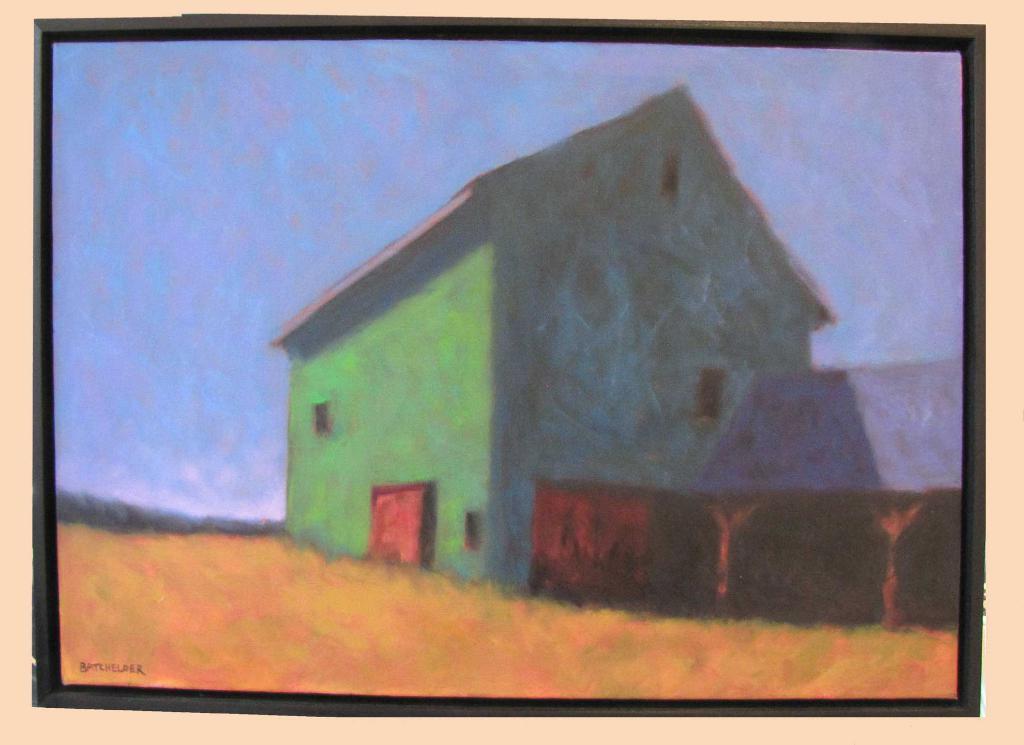Can you describe this image briefly? In this picture I can see painting, it looks like a house and I can see text at the bottom left corner of the picture. 